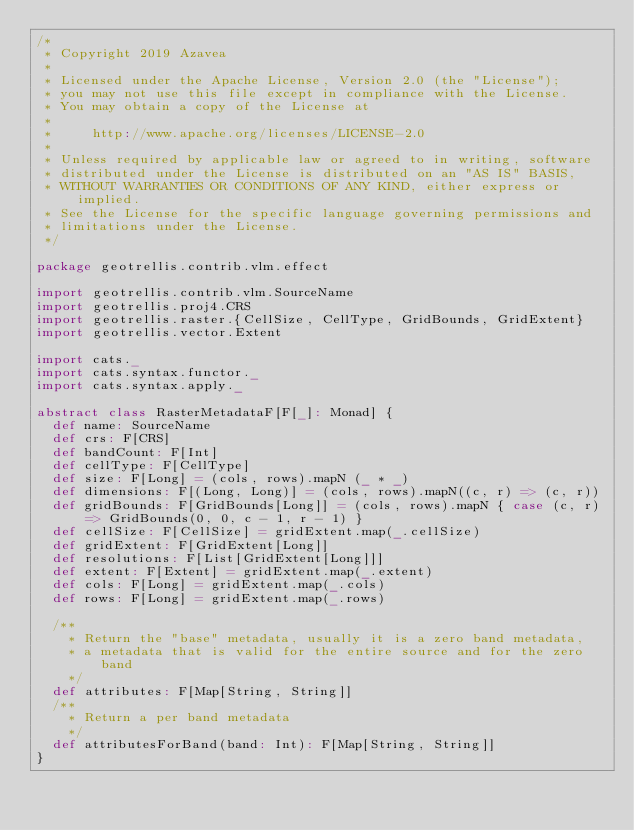<code> <loc_0><loc_0><loc_500><loc_500><_Scala_>/*
 * Copyright 2019 Azavea
 *
 * Licensed under the Apache License, Version 2.0 (the "License");
 * you may not use this file except in compliance with the License.
 * You may obtain a copy of the License at
 *
 *     http://www.apache.org/licenses/LICENSE-2.0
 *
 * Unless required by applicable law or agreed to in writing, software
 * distributed under the License is distributed on an "AS IS" BASIS,
 * WITHOUT WARRANTIES OR CONDITIONS OF ANY KIND, either express or implied.
 * See the License for the specific language governing permissions and
 * limitations under the License.
 */

package geotrellis.contrib.vlm.effect

import geotrellis.contrib.vlm.SourceName
import geotrellis.proj4.CRS
import geotrellis.raster.{CellSize, CellType, GridBounds, GridExtent}
import geotrellis.vector.Extent

import cats._
import cats.syntax.functor._
import cats.syntax.apply._

abstract class RasterMetadataF[F[_]: Monad] {
  def name: SourceName
  def crs: F[CRS]
  def bandCount: F[Int]
  def cellType: F[CellType]
  def size: F[Long] = (cols, rows).mapN (_ * _)
  def dimensions: F[(Long, Long)] = (cols, rows).mapN((c, r) => (c, r))
  def gridBounds: F[GridBounds[Long]] = (cols, rows).mapN { case (c, r) => GridBounds(0, 0, c - 1, r - 1) }
  def cellSize: F[CellSize] = gridExtent.map(_.cellSize)
  def gridExtent: F[GridExtent[Long]]
  def resolutions: F[List[GridExtent[Long]]]
  def extent: F[Extent] = gridExtent.map(_.extent)
  def cols: F[Long] = gridExtent.map(_.cols)
  def rows: F[Long] = gridExtent.map(_.rows)

  /**
    * Return the "base" metadata, usually it is a zero band metadata,
    * a metadata that is valid for the entire source and for the zero band
    */
  def attributes: F[Map[String, String]]
  /**
    * Return a per band metadata
    */
  def attributesForBand(band: Int): F[Map[String, String]]
}
</code> 